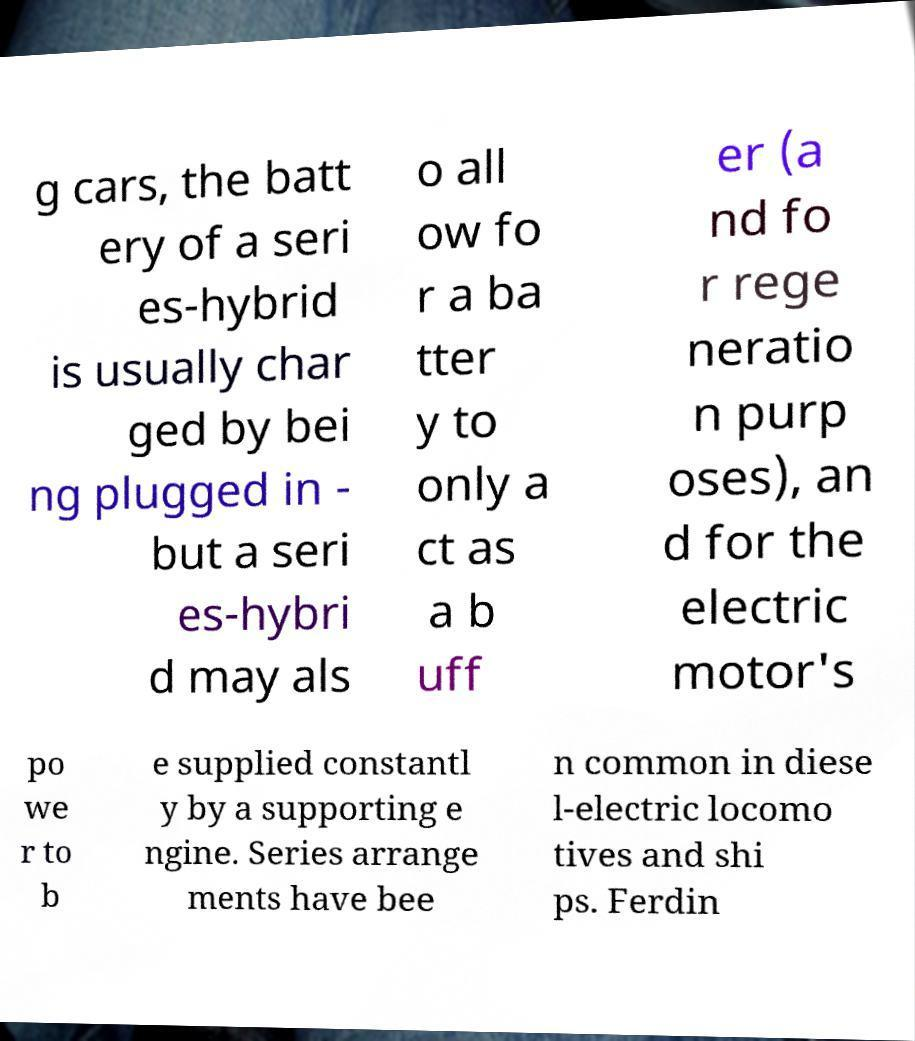Could you assist in decoding the text presented in this image and type it out clearly? g cars, the batt ery of a seri es-hybrid is usually char ged by bei ng plugged in - but a seri es-hybri d may als o all ow fo r a ba tter y to only a ct as a b uff er (a nd fo r rege neratio n purp oses), an d for the electric motor's po we r to b e supplied constantl y by a supporting e ngine. Series arrange ments have bee n common in diese l-electric locomo tives and shi ps. Ferdin 